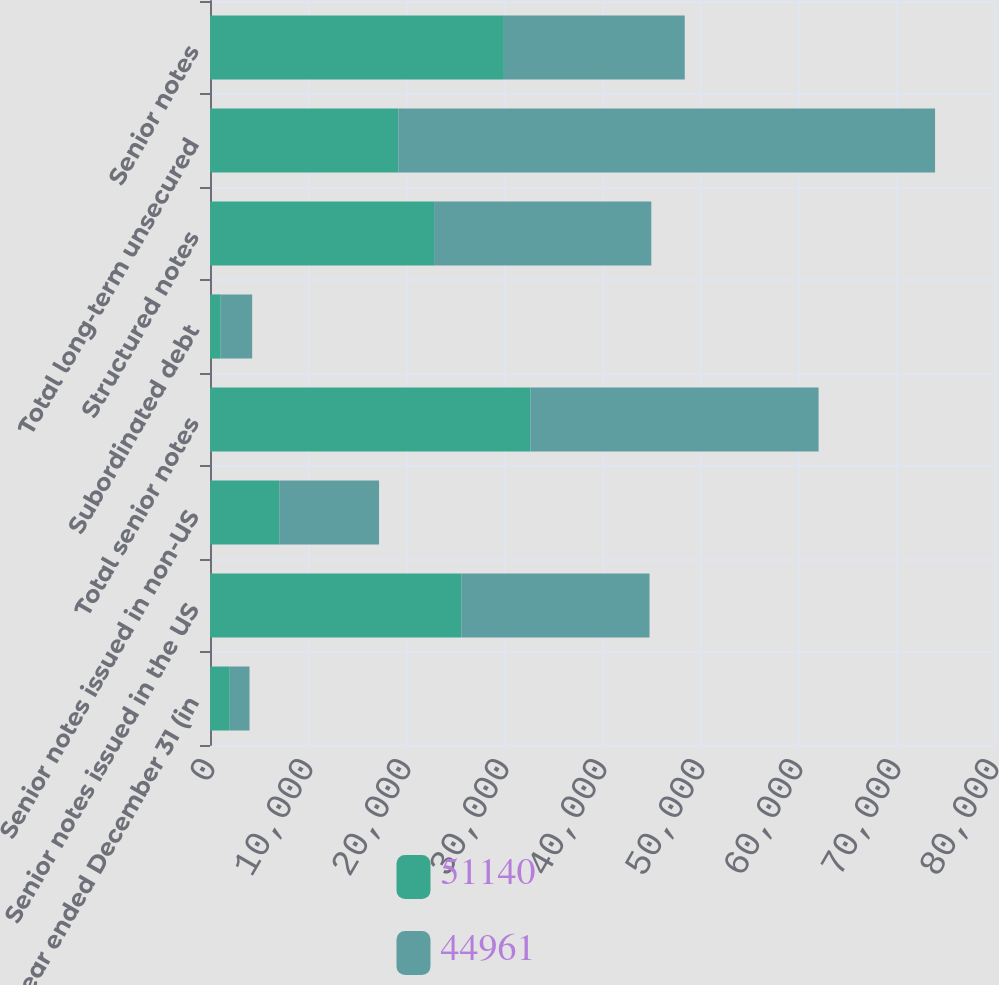Convert chart. <chart><loc_0><loc_0><loc_500><loc_500><stacked_bar_chart><ecel><fcel>Year ended December 31 (in<fcel>Senior notes issued in the US<fcel>Senior notes issued in non-US<fcel>Total senior notes<fcel>Subordinated debt<fcel>Structured notes<fcel>Total long-term unsecured<fcel>Senior notes<nl><fcel>51140<fcel>2016<fcel>25639<fcel>7063<fcel>32702<fcel>1093<fcel>22865<fcel>19212<fcel>29989<nl><fcel>44961<fcel>2015<fcel>19212<fcel>10188<fcel>29400<fcel>3210<fcel>22165<fcel>54775<fcel>18454<nl></chart> 